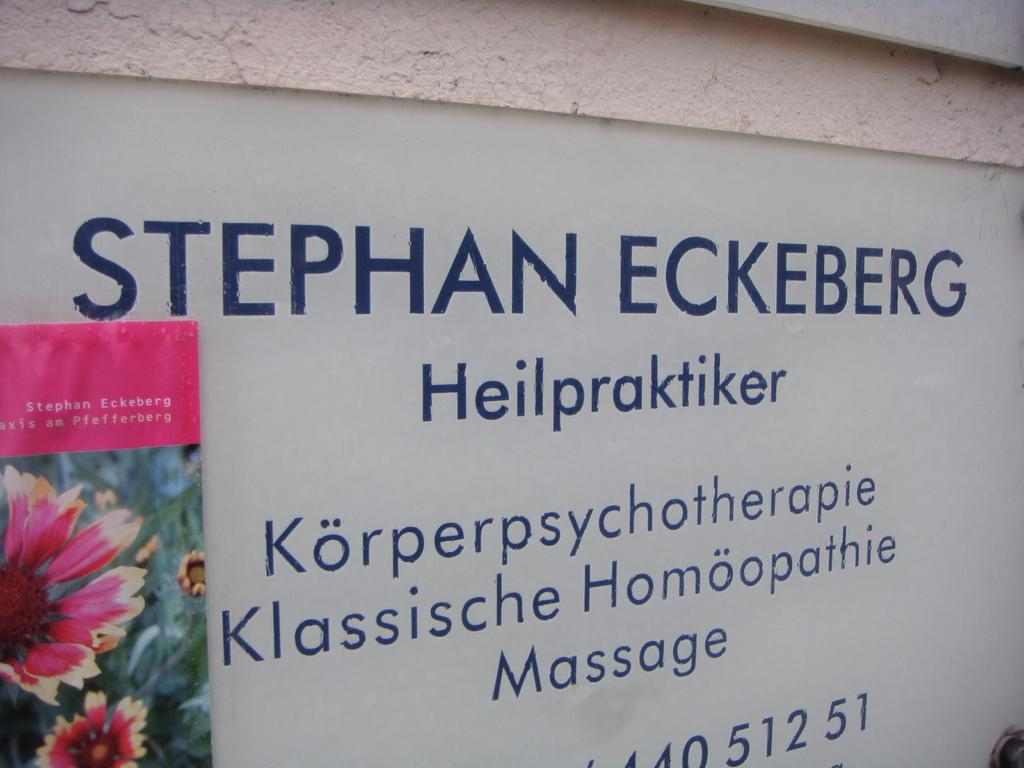What is located on the left side of the image? There is a hoarding on the left side of the image. Where is the hoarding placed? The hoarding is on a wall. What can be seen on the wall besides the hoarding? There are texts written on the wall. Can you tell me how many cherries are hanging from the hoarding in the image? There are no cherries present in the image; the hoarding is on a wall with texts written on it. 